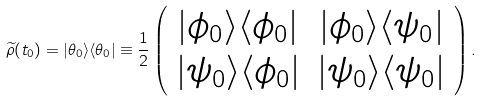Convert formula to latex. <formula><loc_0><loc_0><loc_500><loc_500>\widetilde { \rho } ( t _ { 0 } ) = | \theta _ { 0 } \rangle \langle \theta _ { 0 } | \equiv \frac { 1 } { 2 } \left ( \begin{array} { c c } | \phi _ { 0 } \rangle \langle \phi _ { 0 } | & | \phi _ { 0 } \rangle \langle \psi _ { 0 } | \\ | \psi _ { 0 } \rangle \langle \phi _ { 0 } | & | \psi _ { 0 } \rangle \langle \psi _ { 0 } | \end{array} \right ) .</formula> 